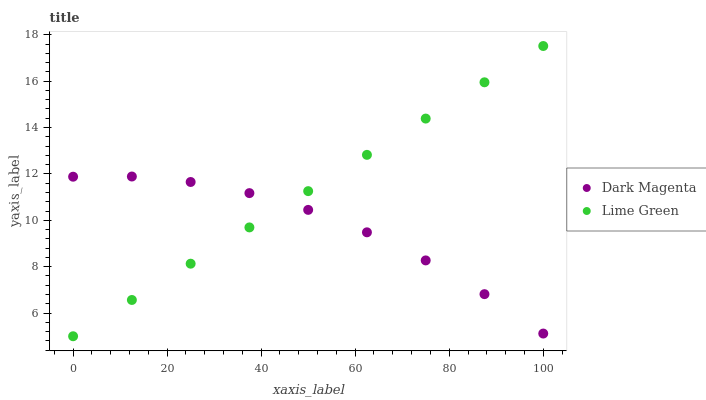Does Dark Magenta have the minimum area under the curve?
Answer yes or no. Yes. Does Lime Green have the maximum area under the curve?
Answer yes or no. Yes. Does Dark Magenta have the maximum area under the curve?
Answer yes or no. No. Is Lime Green the smoothest?
Answer yes or no. Yes. Is Dark Magenta the roughest?
Answer yes or no. Yes. Is Dark Magenta the smoothest?
Answer yes or no. No. Does Lime Green have the lowest value?
Answer yes or no. Yes. Does Dark Magenta have the lowest value?
Answer yes or no. No. Does Lime Green have the highest value?
Answer yes or no. Yes. Does Dark Magenta have the highest value?
Answer yes or no. No. Does Lime Green intersect Dark Magenta?
Answer yes or no. Yes. Is Lime Green less than Dark Magenta?
Answer yes or no. No. Is Lime Green greater than Dark Magenta?
Answer yes or no. No. 